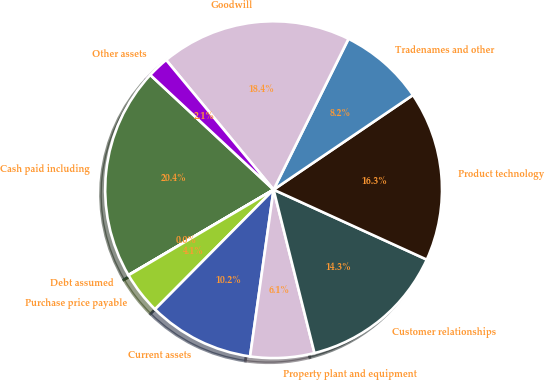Convert chart. <chart><loc_0><loc_0><loc_500><loc_500><pie_chart><fcel>Cash paid including<fcel>Debt assumed<fcel>Purchase price payable<fcel>Current assets<fcel>Property plant and equipment<fcel>Customer relationships<fcel>Product technology<fcel>Tradenames and other<fcel>Goodwill<fcel>Other assets<nl><fcel>20.39%<fcel>0.02%<fcel>4.09%<fcel>10.2%<fcel>6.13%<fcel>14.28%<fcel>16.31%<fcel>8.17%<fcel>18.35%<fcel>2.06%<nl></chart> 